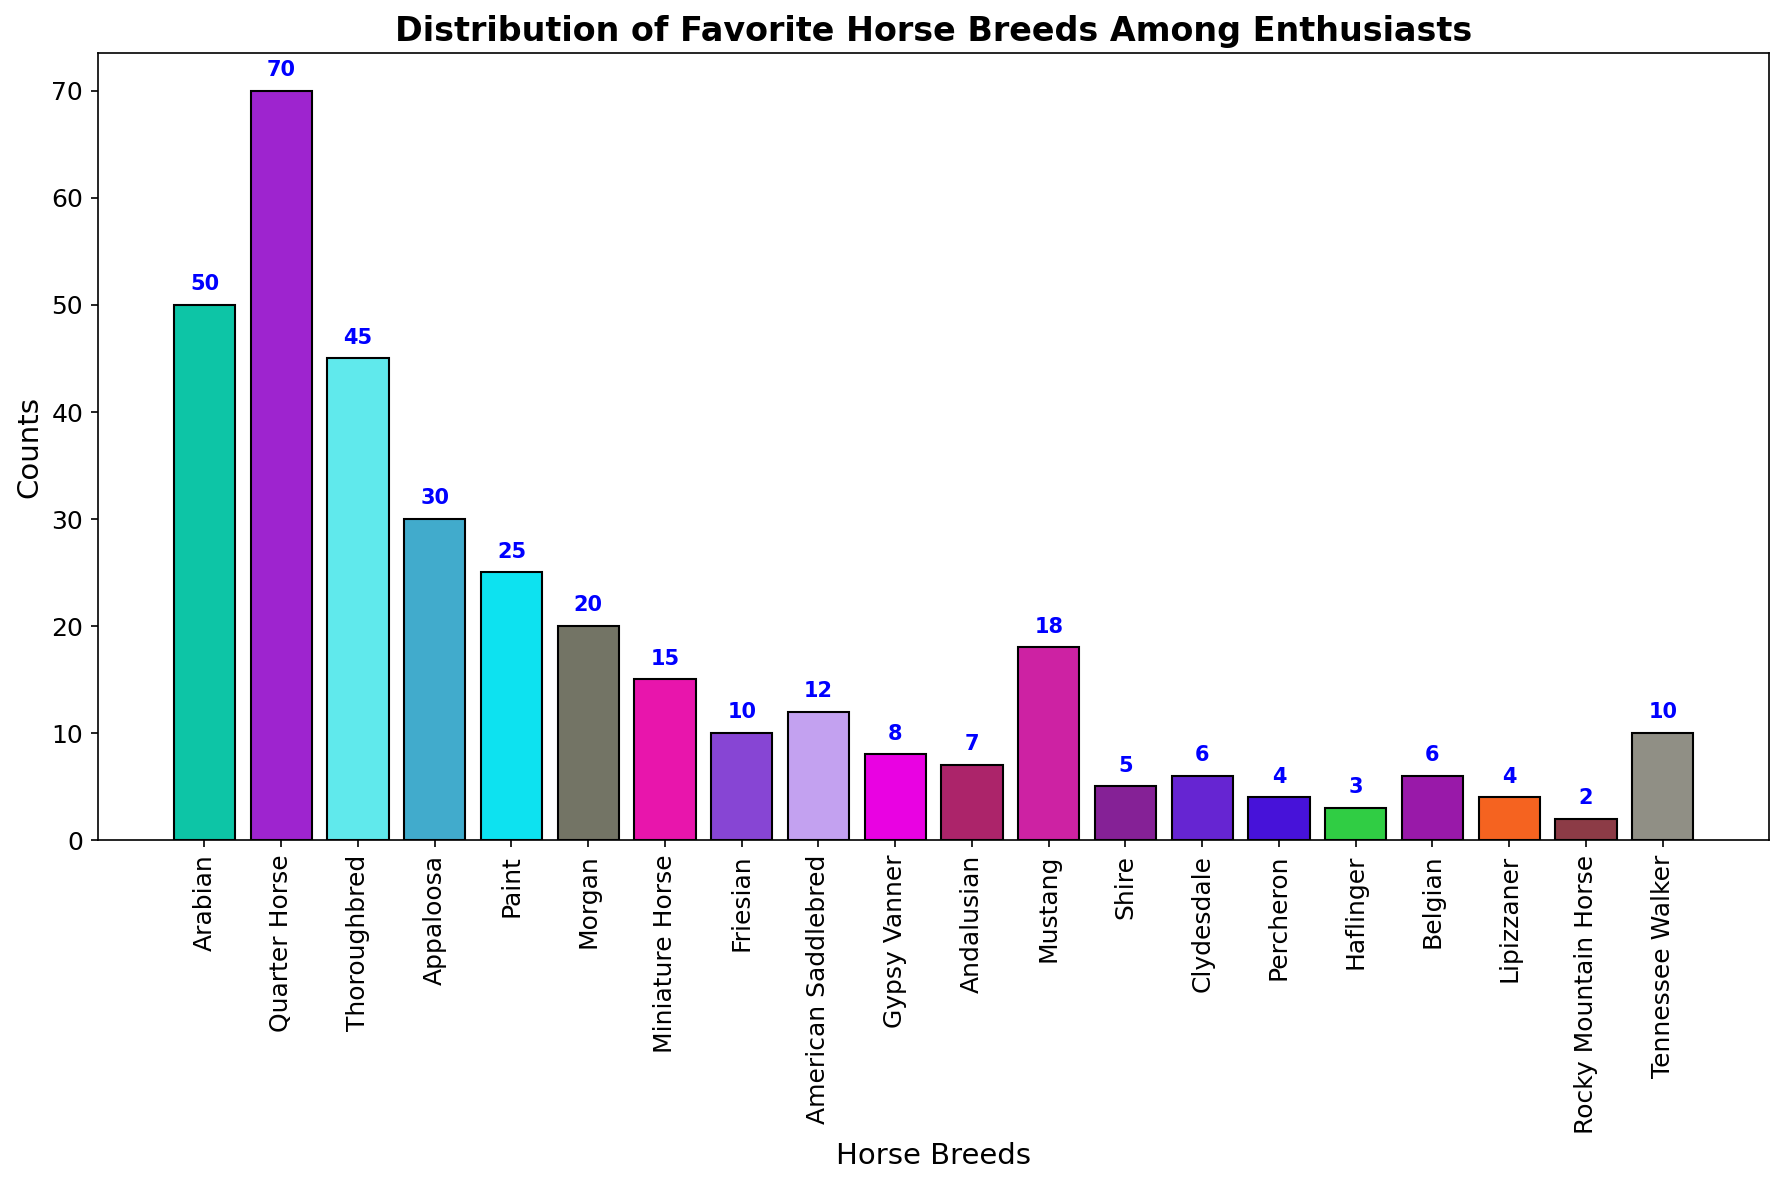Which breed has the highest count of enthusiasts? By observing the heights of the bars, the highest bar corresponds to the Quarter Horse breed.
Answer: Quarter Horse Which horse breed has fewer enthusiasts: Friesian or Morgan? By comparing the heights of the bars, the Friesian has a shorter bar than the Morgan.
Answer: Friesian What's the difference in count between the most and least popular breeds? The highest count is for Quarter Horse (70) and the lowest is for Rocky Mountain Horse (2). The difference is 70 - 2.
Answer: 68 How many breeds have more than 30 enthusiasts? By inspecting the heights of the bars, Arabian, Quarter Horse, and Thoroughbred have counts above 30.
Answer: 3 Are there more enthusiasts for the American Saddlebred or the Andalusian breed? By comparing the heights of the respective bars, American Saddlebred has a taller bar than Andalusian.
Answer: American Saddlebred What is the combined count for Paint and Appaloosa breeds? The counts for Paint and Appaloosa are 25 and 30 respectively. The sum is 25 + 30.
Answer: 55 Which breed has a count closest to 20 enthusiasts? By checking the bars, the breed closest to 20 is Morgan, with a count of 20.
Answer: Morgan How do the counts for the Thoroughbred and Mustang breeds compare? By observing the heights, Thoroughbred has a taller bar at 45 while Mustang has 18.
Answer: Thoroughbred Which breeds have exactly 6 enthusiasts each? By examining the labels and heights of the bars, Clydesdale and Belgian both have counts of 6.
Answer: Clydesdale, Belgian What is the average count of enthusiasts for Friesian, American Saddlebred, and Tennessee Walker combined? Adding the counts for Friesian (10), American Saddlebred (12), and Tennessee Walker (10) gives 32. The average is 32/3.
Answer: 10.67 